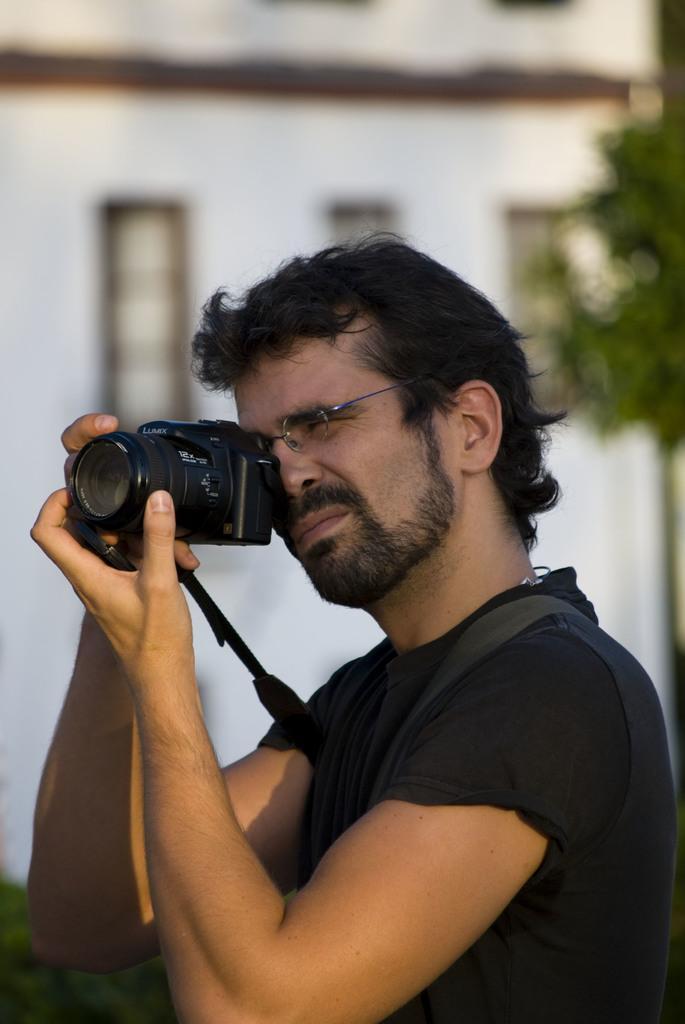Describe this image in one or two sentences. This picture shows a person holding a camera with his both hands and in the backdrop there is a tree and a building 